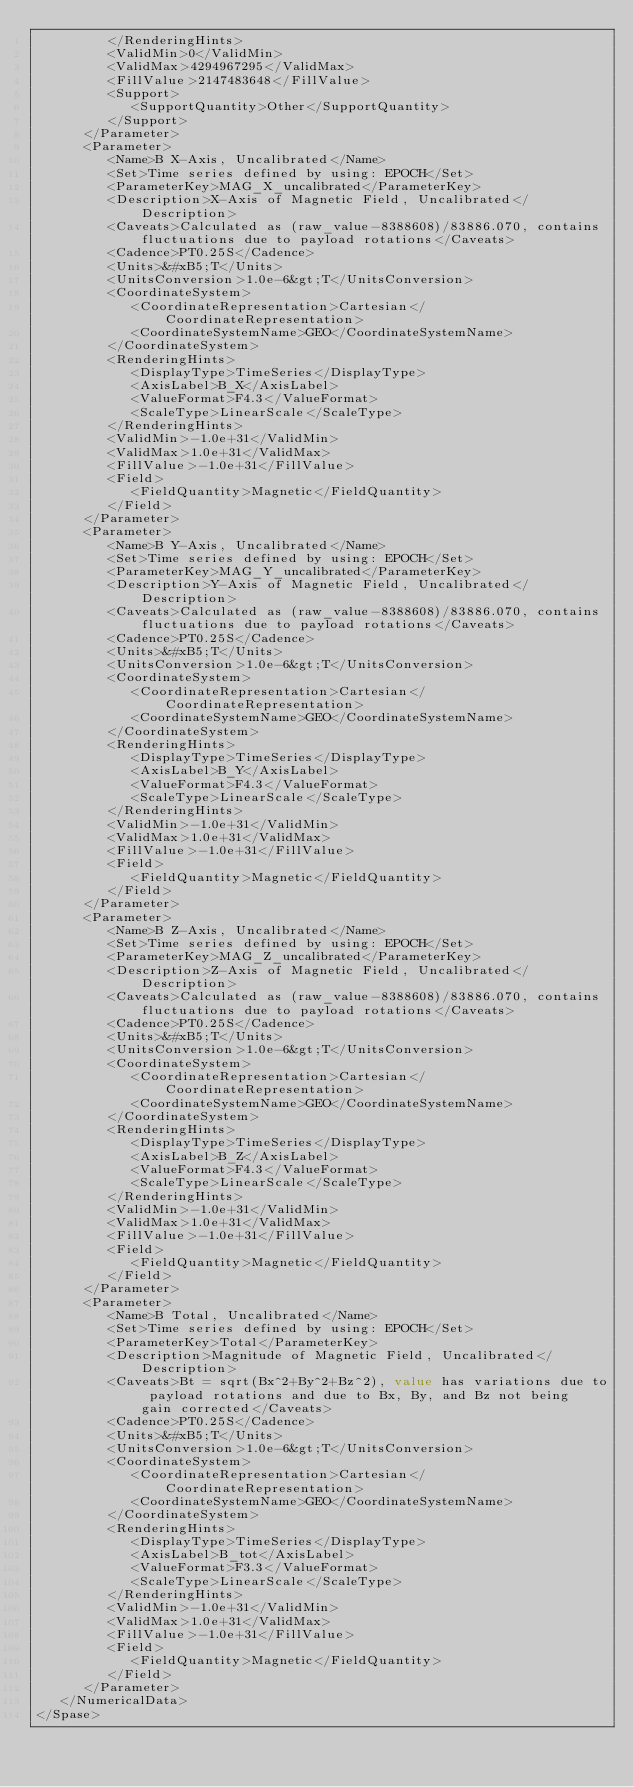Convert code to text. <code><loc_0><loc_0><loc_500><loc_500><_XML_>         </RenderingHints>
         <ValidMin>0</ValidMin>
         <ValidMax>4294967295</ValidMax>
         <FillValue>2147483648</FillValue>
         <Support>
            <SupportQuantity>Other</SupportQuantity>
         </Support>
      </Parameter>
      <Parameter>
         <Name>B X-Axis, Uncalibrated</Name>
         <Set>Time series defined by using: EPOCH</Set>
         <ParameterKey>MAG_X_uncalibrated</ParameterKey>
         <Description>X-Axis of Magnetic Field, Uncalibrated</Description>
         <Caveats>Calculated as (raw_value-8388608)/83886.070, contains fluctuations due to payload rotations</Caveats>
         <Cadence>PT0.25S</Cadence>
         <Units>&#xB5;T</Units>
         <UnitsConversion>1.0e-6&gt;T</UnitsConversion>
         <CoordinateSystem>
            <CoordinateRepresentation>Cartesian</CoordinateRepresentation>
            <CoordinateSystemName>GEO</CoordinateSystemName>
         </CoordinateSystem>
         <RenderingHints>
            <DisplayType>TimeSeries</DisplayType>
            <AxisLabel>B_X</AxisLabel>
            <ValueFormat>F4.3</ValueFormat>
            <ScaleType>LinearScale</ScaleType>
         </RenderingHints>
         <ValidMin>-1.0e+31</ValidMin>
         <ValidMax>1.0e+31</ValidMax>
         <FillValue>-1.0e+31</FillValue>
         <Field>
            <FieldQuantity>Magnetic</FieldQuantity>
         </Field>
      </Parameter>
      <Parameter>
         <Name>B Y-Axis, Uncalibrated</Name>
         <Set>Time series defined by using: EPOCH</Set>
         <ParameterKey>MAG_Y_uncalibrated</ParameterKey>
         <Description>Y-Axis of Magnetic Field, Uncalibrated</Description>
         <Caveats>Calculated as (raw_value-8388608)/83886.070, contains fluctuations due to payload rotations</Caveats>
         <Cadence>PT0.25S</Cadence>
         <Units>&#xB5;T</Units>
         <UnitsConversion>1.0e-6&gt;T</UnitsConversion>
         <CoordinateSystem>
            <CoordinateRepresentation>Cartesian</CoordinateRepresentation>
            <CoordinateSystemName>GEO</CoordinateSystemName>
         </CoordinateSystem>
         <RenderingHints>
            <DisplayType>TimeSeries</DisplayType>
            <AxisLabel>B_Y</AxisLabel>
            <ValueFormat>F4.3</ValueFormat>
            <ScaleType>LinearScale</ScaleType>
         </RenderingHints>
         <ValidMin>-1.0e+31</ValidMin>
         <ValidMax>1.0e+31</ValidMax>
         <FillValue>-1.0e+31</FillValue>
         <Field>
            <FieldQuantity>Magnetic</FieldQuantity>
         </Field>
      </Parameter>
      <Parameter>
         <Name>B Z-Axis, Uncalibrated</Name>
         <Set>Time series defined by using: EPOCH</Set>
         <ParameterKey>MAG_Z_uncalibrated</ParameterKey>
         <Description>Z-Axis of Magnetic Field, Uncalibrated</Description>
         <Caveats>Calculated as (raw_value-8388608)/83886.070, contains fluctuations due to payload rotations</Caveats>
         <Cadence>PT0.25S</Cadence>
         <Units>&#xB5;T</Units>
         <UnitsConversion>1.0e-6&gt;T</UnitsConversion>
         <CoordinateSystem>
            <CoordinateRepresentation>Cartesian</CoordinateRepresentation>
            <CoordinateSystemName>GEO</CoordinateSystemName>
         </CoordinateSystem>
         <RenderingHints>
            <DisplayType>TimeSeries</DisplayType>
            <AxisLabel>B_Z</AxisLabel>
            <ValueFormat>F4.3</ValueFormat>
            <ScaleType>LinearScale</ScaleType>
         </RenderingHints>
         <ValidMin>-1.0e+31</ValidMin>
         <ValidMax>1.0e+31</ValidMax>
         <FillValue>-1.0e+31</FillValue>
         <Field>
            <FieldQuantity>Magnetic</FieldQuantity>
         </Field>
      </Parameter>
      <Parameter>
         <Name>B Total, Uncalibrated</Name>
         <Set>Time series defined by using: EPOCH</Set>
         <ParameterKey>Total</ParameterKey>
         <Description>Magnitude of Magnetic Field, Uncalibrated</Description>
         <Caveats>Bt = sqrt(Bx^2+By^2+Bz^2), value has variations due to payload rotations and due to Bx, By, and Bz not being gain corrected</Caveats>
         <Cadence>PT0.25S</Cadence>
         <Units>&#xB5;T</Units>
         <UnitsConversion>1.0e-6&gt;T</UnitsConversion>
         <CoordinateSystem>
            <CoordinateRepresentation>Cartesian</CoordinateRepresentation>
            <CoordinateSystemName>GEO</CoordinateSystemName>
         </CoordinateSystem>
         <RenderingHints>
            <DisplayType>TimeSeries</DisplayType>
            <AxisLabel>B_tot</AxisLabel>
            <ValueFormat>F3.3</ValueFormat>
            <ScaleType>LinearScale</ScaleType>
         </RenderingHints>
         <ValidMin>-1.0e+31</ValidMin>
         <ValidMax>1.0e+31</ValidMax>
         <FillValue>-1.0e+31</FillValue>
         <Field>
            <FieldQuantity>Magnetic</FieldQuantity>
         </Field>
      </Parameter>
   </NumericalData>
</Spase>
</code> 